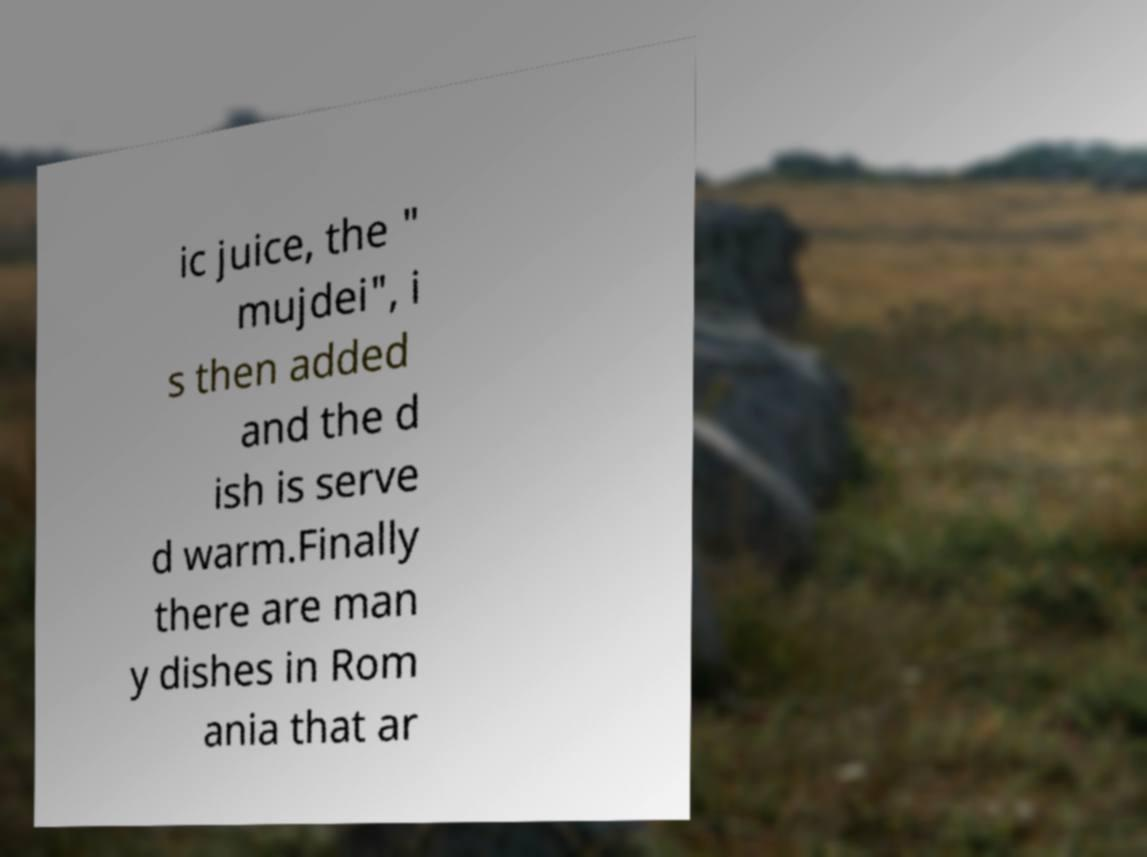Can you accurately transcribe the text from the provided image for me? ic juice, the " mujdei", i s then added and the d ish is serve d warm.Finally there are man y dishes in Rom ania that ar 